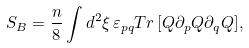Convert formula to latex. <formula><loc_0><loc_0><loc_500><loc_500>S _ { B } = \frac { n } { 8 } \int d ^ { 2 } \xi \, \varepsilon _ { p q } T r \, [ Q \partial _ { p } Q \partial _ { q } Q ] ,</formula> 